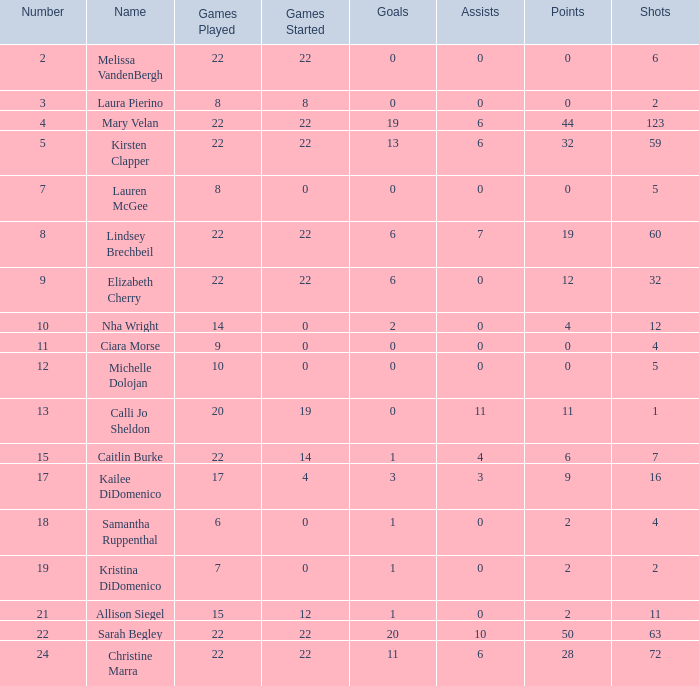How many names are listed for the player with 50 points? 1.0. 